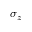Convert formula to latex. <formula><loc_0><loc_0><loc_500><loc_500>\sigma _ { z }</formula> 